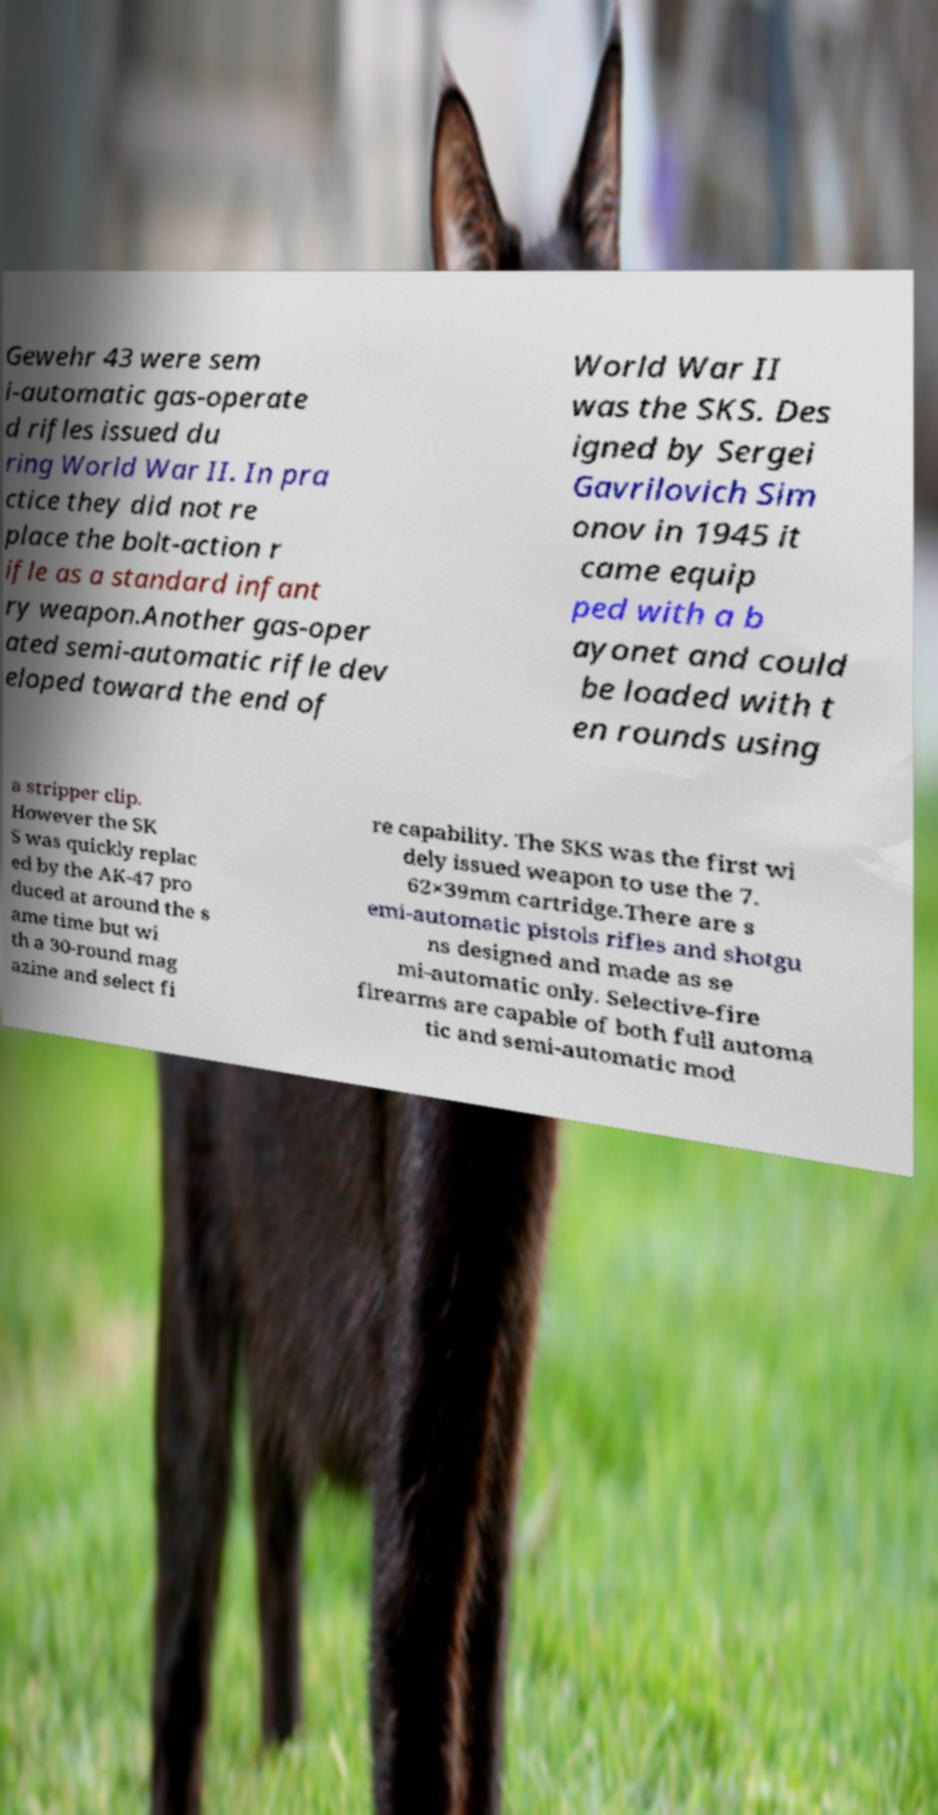What messages or text are displayed in this image? I need them in a readable, typed format. Gewehr 43 were sem i-automatic gas-operate d rifles issued du ring World War II. In pra ctice they did not re place the bolt-action r ifle as a standard infant ry weapon.Another gas-oper ated semi-automatic rifle dev eloped toward the end of World War II was the SKS. Des igned by Sergei Gavrilovich Sim onov in 1945 it came equip ped with a b ayonet and could be loaded with t en rounds using a stripper clip. However the SK S was quickly replac ed by the AK-47 pro duced at around the s ame time but wi th a 30-round mag azine and select fi re capability. The SKS was the first wi dely issued weapon to use the 7. 62×39mm cartridge.There are s emi-automatic pistols rifles and shotgu ns designed and made as se mi-automatic only. Selective-fire firearms are capable of both full automa tic and semi-automatic mod 